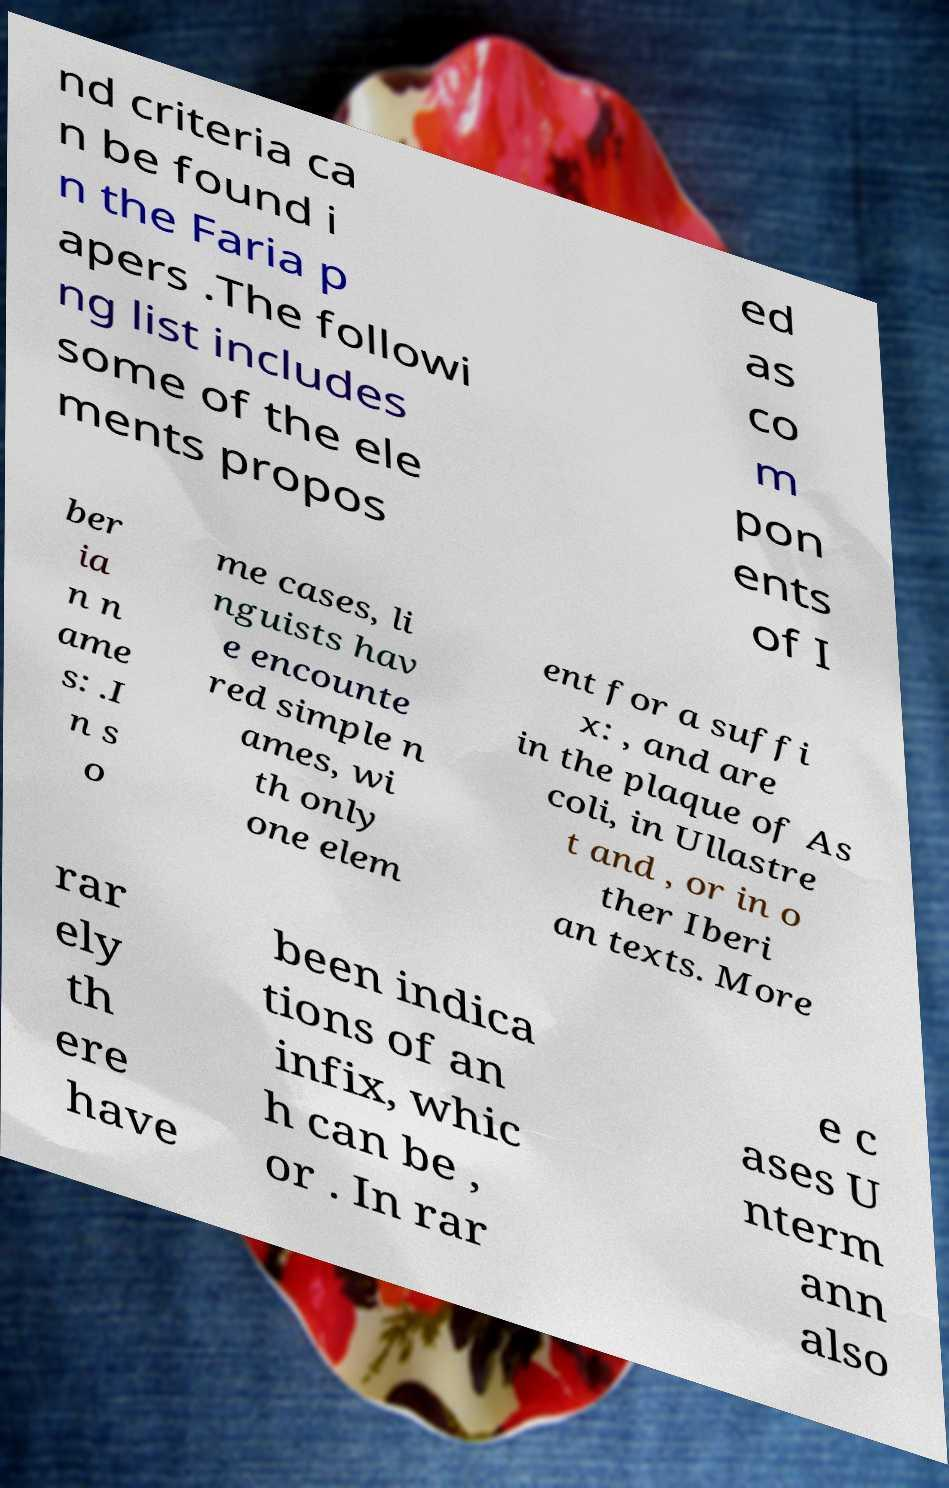Please identify and transcribe the text found in this image. nd criteria ca n be found i n the Faria p apers .The followi ng list includes some of the ele ments propos ed as co m pon ents of I ber ia n n ame s: .I n s o me cases, li nguists hav e encounte red simple n ames, wi th only one elem ent for a suffi x: , and are in the plaque of As coli, in Ullastre t and , or in o ther Iberi an texts. More rar ely th ere have been indica tions of an infix, whic h can be , or . In rar e c ases U nterm ann also 